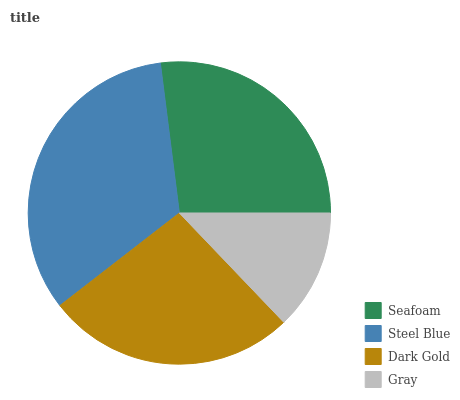Is Gray the minimum?
Answer yes or no. Yes. Is Steel Blue the maximum?
Answer yes or no. Yes. Is Dark Gold the minimum?
Answer yes or no. No. Is Dark Gold the maximum?
Answer yes or no. No. Is Steel Blue greater than Dark Gold?
Answer yes or no. Yes. Is Dark Gold less than Steel Blue?
Answer yes or no. Yes. Is Dark Gold greater than Steel Blue?
Answer yes or no. No. Is Steel Blue less than Dark Gold?
Answer yes or no. No. Is Seafoam the high median?
Answer yes or no. Yes. Is Dark Gold the low median?
Answer yes or no. Yes. Is Gray the high median?
Answer yes or no. No. Is Steel Blue the low median?
Answer yes or no. No. 